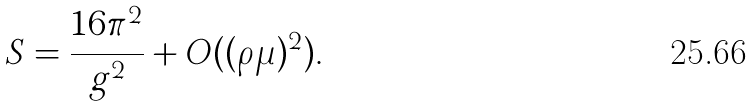Convert formula to latex. <formula><loc_0><loc_0><loc_500><loc_500>S = \frac { 1 6 \pi ^ { 2 } } { g ^ { 2 } } + O ( ( \rho \mu ) ^ { 2 } ) .</formula> 